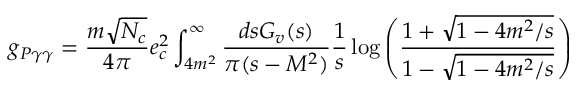<formula> <loc_0><loc_0><loc_500><loc_500>g _ { P \gamma \gamma } = \frac { m \sqrt { N _ { c } } } { 4 \pi } e _ { c } ^ { 2 } \int _ { 4 m ^ { 2 } } ^ { \infty } \frac { d s G _ { v } ( s ) } { \pi ( s - M ^ { 2 } ) } \frac { 1 } { s } \log \left ( { \frac { 1 + \sqrt { 1 - 4 m ^ { 2 } / s } } { 1 - \sqrt { 1 - 4 m ^ { 2 } / s } } } \right )</formula> 